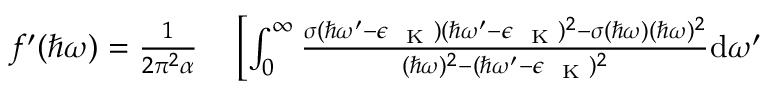<formula> <loc_0><loc_0><loc_500><loc_500>\begin{array} { r l } { f ^ { \prime } ( \hbar { \omega } ) = \frac { 1 } { 2 \pi ^ { 2 } \alpha } } & \left [ \int _ { 0 } ^ { \infty } \frac { \sigma ( \hbar { \omega } ^ { \prime } - \epsilon _ { K } ) ( \hbar { \omega } ^ { \prime } - \epsilon _ { K } ) ^ { 2 } - \sigma ( \hbar { \omega } ) ( \hbar { \omega } ) ^ { 2 } } { ( \hbar { \omega } ) ^ { 2 } - ( \hbar { \omega } ^ { \prime } - \epsilon _ { K } ) ^ { 2 } } d \omega ^ { \prime } } \end{array}</formula> 